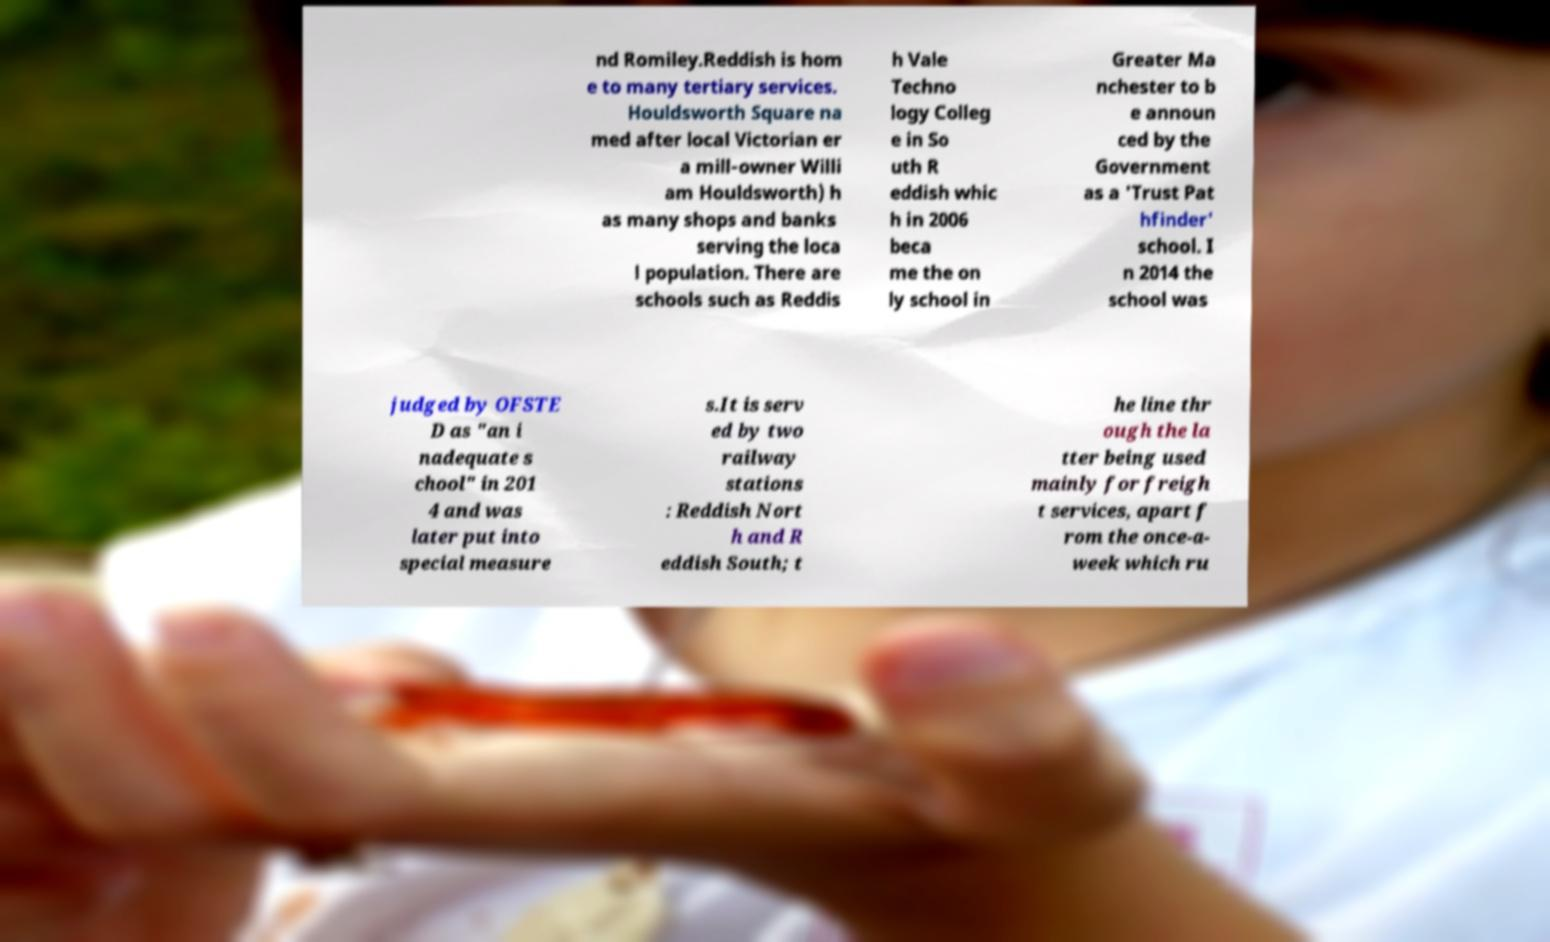I need the written content from this picture converted into text. Can you do that? nd Romiley.Reddish is hom e to many tertiary services. Houldsworth Square na med after local Victorian er a mill-owner Willi am Houldsworth) h as many shops and banks serving the loca l population. There are schools such as Reddis h Vale Techno logy Colleg e in So uth R eddish whic h in 2006 beca me the on ly school in Greater Ma nchester to b e announ ced by the Government as a 'Trust Pat hfinder' school. I n 2014 the school was judged by OFSTE D as "an i nadequate s chool" in 201 4 and was later put into special measure s.It is serv ed by two railway stations : Reddish Nort h and R eddish South; t he line thr ough the la tter being used mainly for freigh t services, apart f rom the once-a- week which ru 